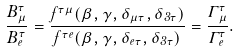<formula> <loc_0><loc_0><loc_500><loc_500>\frac { B _ { \mu } ^ { \tau } } { B _ { e } ^ { \tau } } = \frac { f ^ { \tau \mu } ( \beta , \gamma , \delta _ { \mu \tau } , \delta _ { 3 \tau } ) } { f ^ { \tau e } ( \beta , \gamma , \delta _ { e \tau } , \delta _ { 3 \tau } ) } = \frac { \Gamma _ { \mu } ^ { \tau } } { \Gamma _ { e } ^ { \tau } } .</formula> 